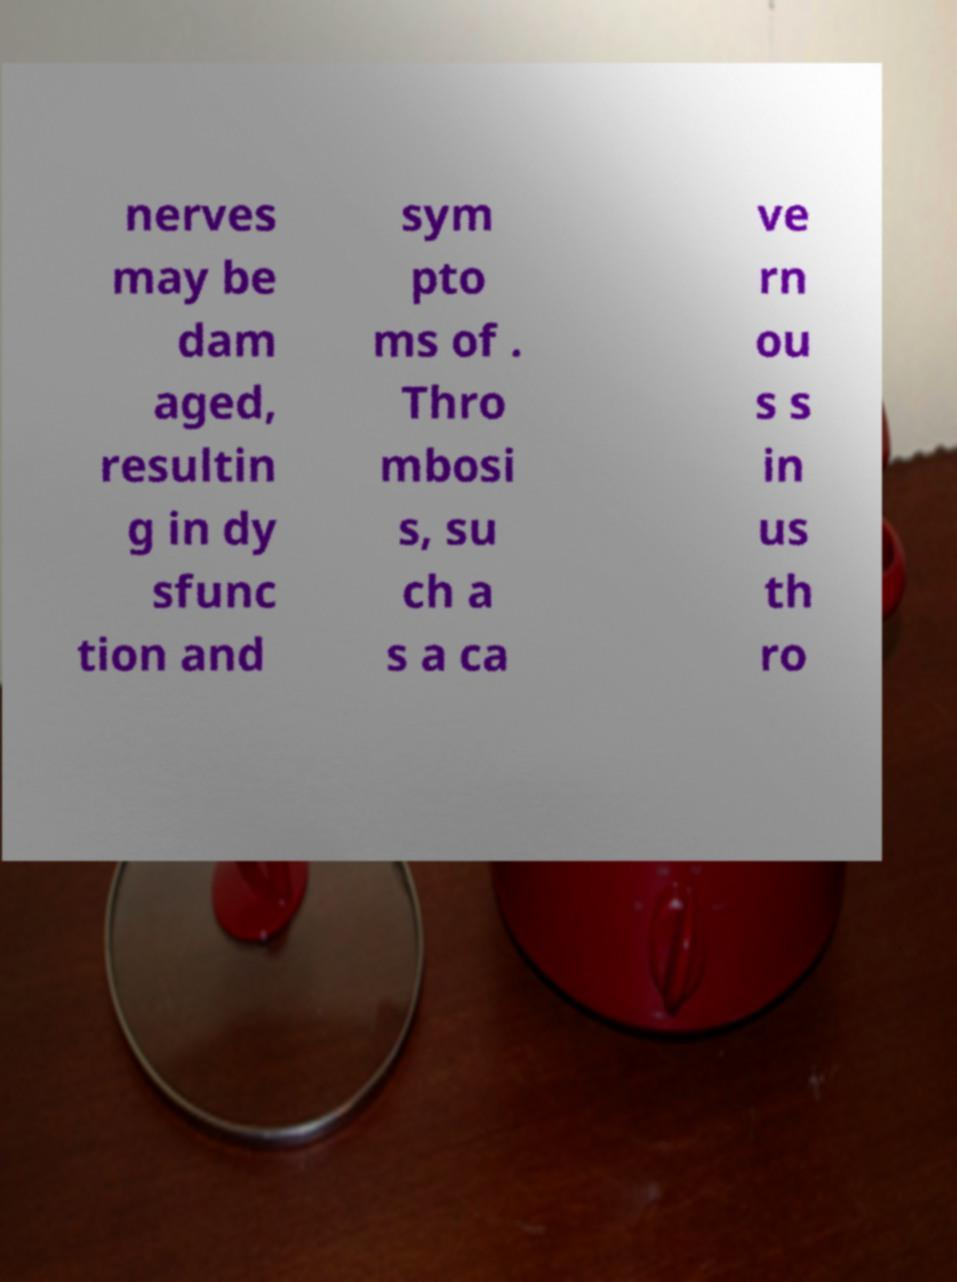Can you accurately transcribe the text from the provided image for me? nerves may be dam aged, resultin g in dy sfunc tion and sym pto ms of . Thro mbosi s, su ch a s a ca ve rn ou s s in us th ro 